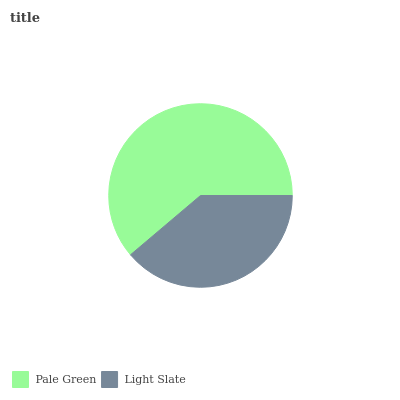Is Light Slate the minimum?
Answer yes or no. Yes. Is Pale Green the maximum?
Answer yes or no. Yes. Is Light Slate the maximum?
Answer yes or no. No. Is Pale Green greater than Light Slate?
Answer yes or no. Yes. Is Light Slate less than Pale Green?
Answer yes or no. Yes. Is Light Slate greater than Pale Green?
Answer yes or no. No. Is Pale Green less than Light Slate?
Answer yes or no. No. Is Pale Green the high median?
Answer yes or no. Yes. Is Light Slate the low median?
Answer yes or no. Yes. Is Light Slate the high median?
Answer yes or no. No. Is Pale Green the low median?
Answer yes or no. No. 